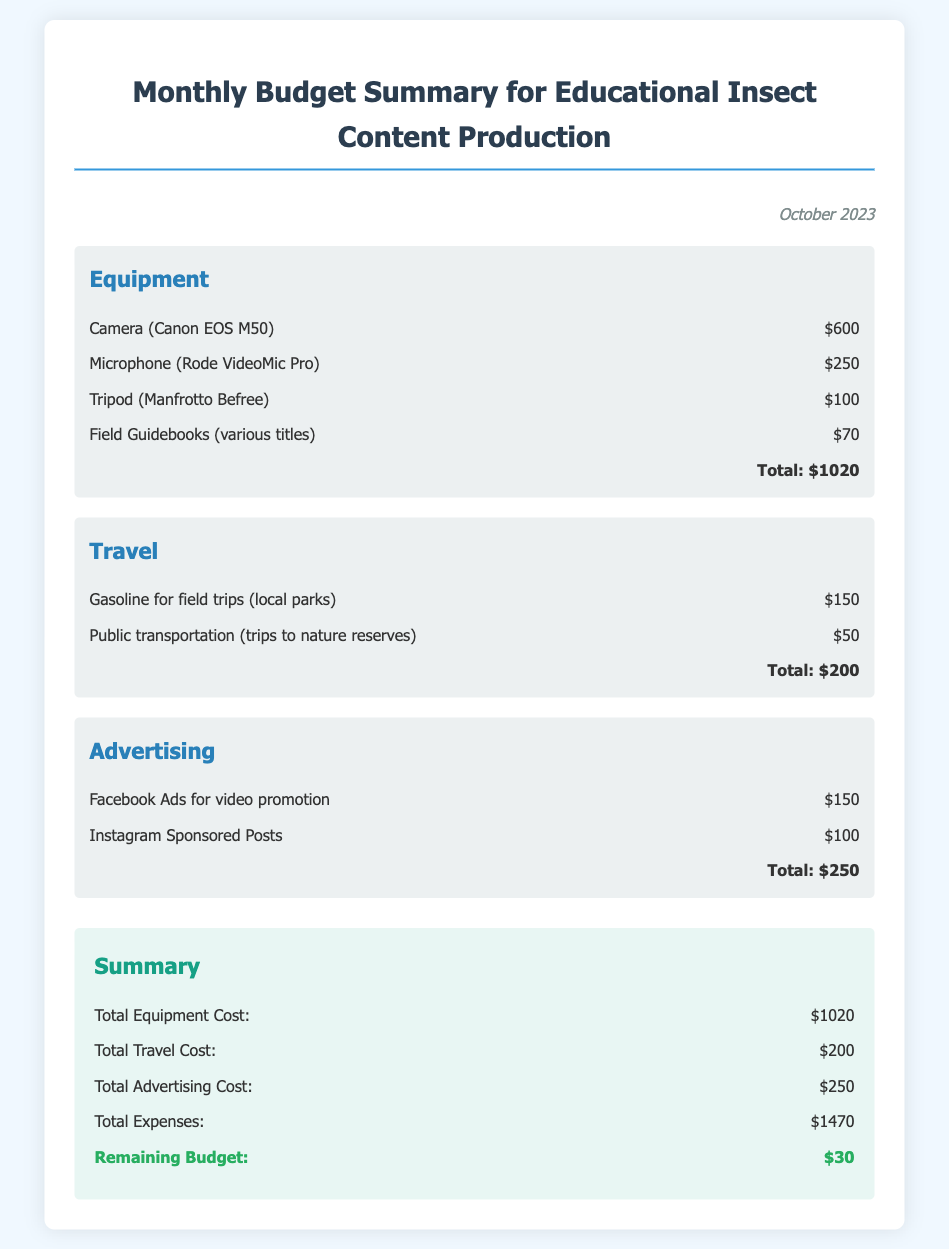What is the date of the budget summary? The date is indicated at the top of the document, stating "October 2023".
Answer: October 2023 What is the total cost for equipment? The summary lists the total equipment cost under the Equipment category, which is $1020.
Answer: $1020 How much was spent on advertising? The total advertising cost is found in the Advertising section, which amounts to $250.
Answer: $250 What is the total travel cost? The document summarizes the travel expenses and lists the total as $200.
Answer: $200 What is the total expenses listed? The total expenses are summarized at the end of the document, amounting to $1470.
Answer: $1470 What is the remaining budget? The remaining budget is specified in the summary section, which shows $30.
Answer: $30 Which equipment costs the most? The highest cost under equipment is for the Camera (Canon EOS M50) which is $600.
Answer: Camera (Canon EOS M50) How many items are listed under advertising? The advertising section contains two items listed.
Answer: Two items What is the purpose of this budget summary? The document is a Monthly Budget Summary for Educational Insect Content Production, detailing expenses.
Answer: Educational Insect Content Production 